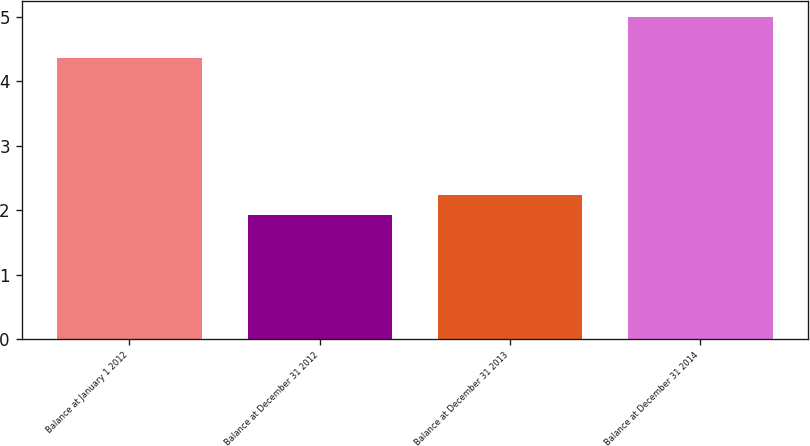Convert chart to OTSL. <chart><loc_0><loc_0><loc_500><loc_500><bar_chart><fcel>Balance at January 1 2012<fcel>Balance at December 31 2012<fcel>Balance at December 31 2013<fcel>Balance at December 31 2014<nl><fcel>4.36<fcel>1.92<fcel>2.23<fcel>5<nl></chart> 